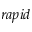<formula> <loc_0><loc_0><loc_500><loc_500>r a p i d</formula> 